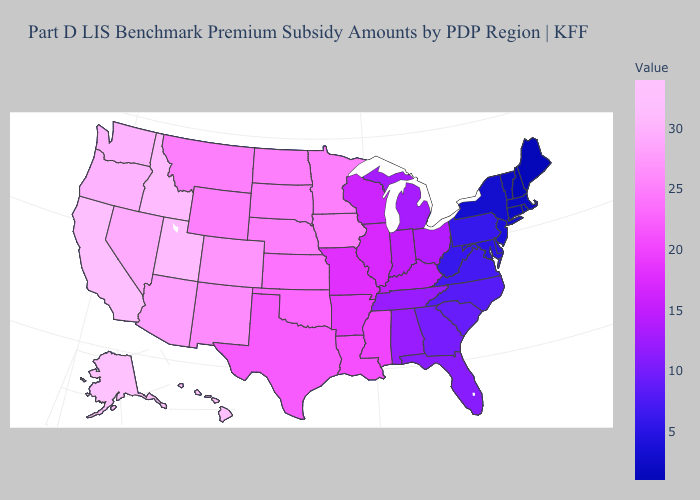Does the map have missing data?
Give a very brief answer. No. Does Montana have the lowest value in the West?
Short answer required. Yes. Which states have the lowest value in the USA?
Write a very short answer. Maine, New Hampshire. Which states have the lowest value in the USA?
Answer briefly. Maine, New Hampshire. 